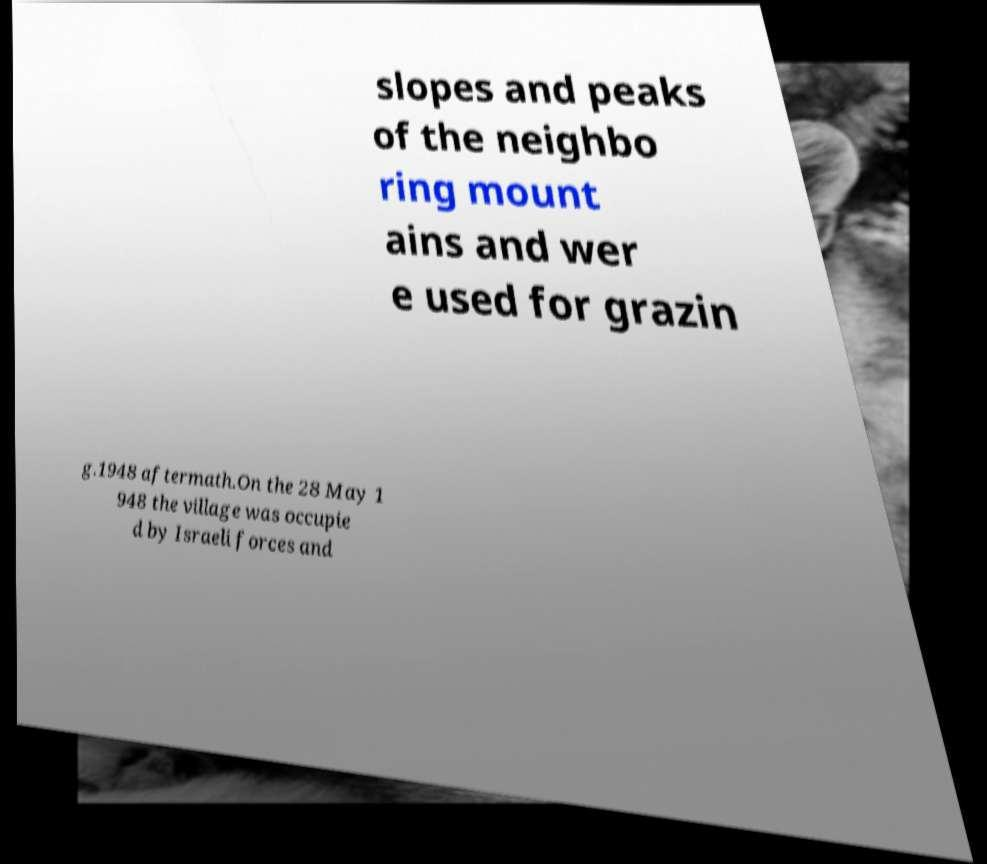What messages or text are displayed in this image? I need them in a readable, typed format. slopes and peaks of the neighbo ring mount ains and wer e used for grazin g.1948 aftermath.On the 28 May 1 948 the village was occupie d by Israeli forces and 